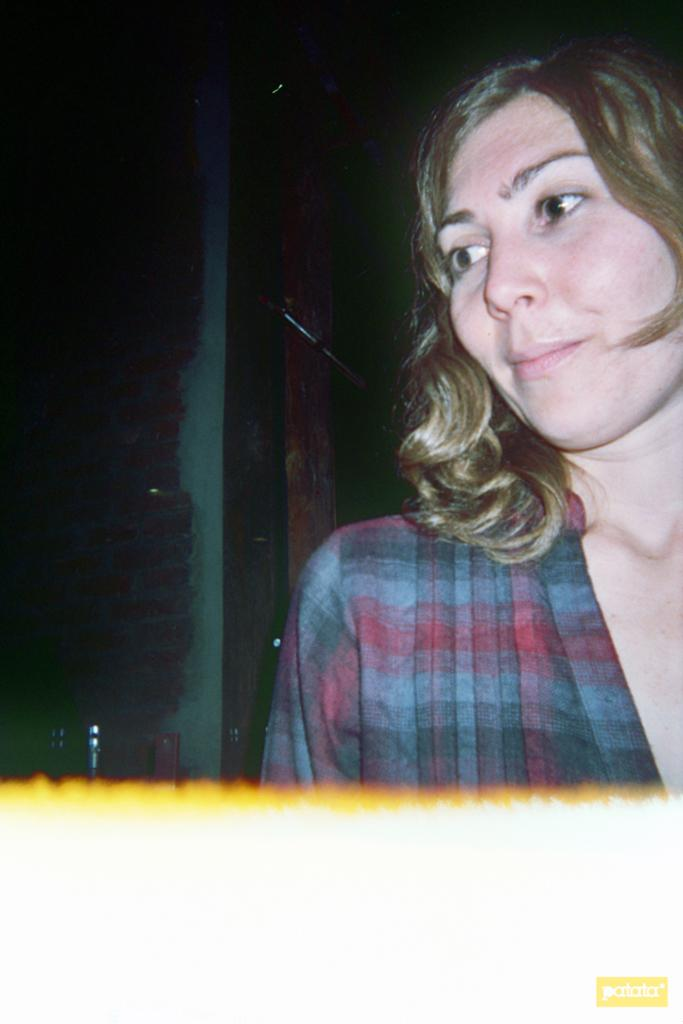Who is the main subject in the image? There is a lady in the image. What can be observed about the background of the image? The background of the image is dark. What color is the bottom part of the image? The bottom part of the image is white in color. Are there any words or letters on the image? Yes, there is text on the image. Can you see an owl holding a spade in the image? No, there is no owl or spade present in the image. Is there a doll interacting with the lady in the image? No, there is no doll present in the image. 